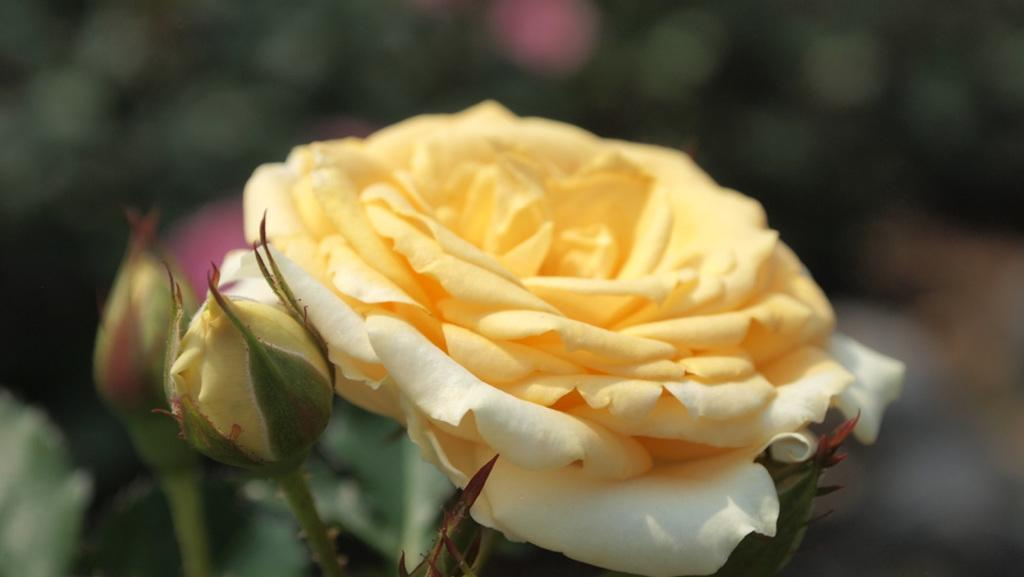What type of living organisms can be seen in the image? Plants can be seen in the image. What specific features can be observed on the plants? The plants have flowers and buds. Can you describe the background of the image? The background of the image is blurry. What type of van can be seen parked near the plants in the image? There is no van present in the image; it only features plants with flowers and buds. Can you describe the kiss between the two flowers in the image? There are no flowers kissing in the image; it only shows plants with flowers and buds. 